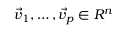<formula> <loc_0><loc_0><loc_500><loc_500>\vec { v } _ { 1 } , \dots c , \vec { v } _ { p } \in R ^ { n }</formula> 